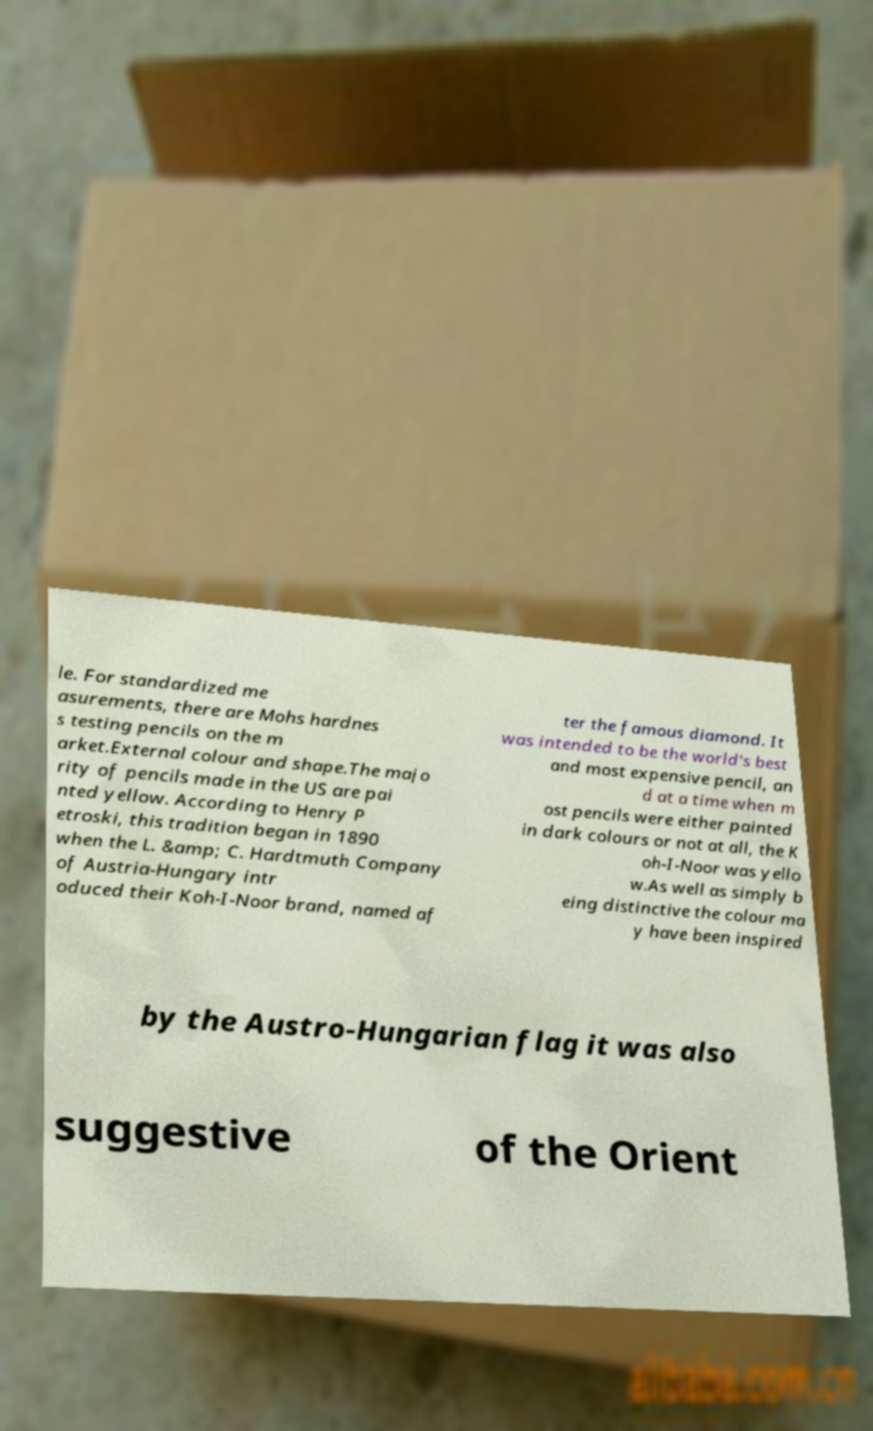For documentation purposes, I need the text within this image transcribed. Could you provide that? le. For standardized me asurements, there are Mohs hardnes s testing pencils on the m arket.External colour and shape.The majo rity of pencils made in the US are pai nted yellow. According to Henry P etroski, this tradition began in 1890 when the L. &amp; C. Hardtmuth Company of Austria-Hungary intr oduced their Koh-I-Noor brand, named af ter the famous diamond. It was intended to be the world's best and most expensive pencil, an d at a time when m ost pencils were either painted in dark colours or not at all, the K oh-I-Noor was yello w.As well as simply b eing distinctive the colour ma y have been inspired by the Austro-Hungarian flag it was also suggestive of the Orient 